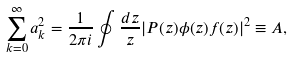Convert formula to latex. <formula><loc_0><loc_0><loc_500><loc_500>\sum _ { k = 0 } ^ { \infty } a _ { k } ^ { 2 } = \frac { 1 } { 2 \pi i } \oint \frac { d z } { z } | P ( z ) \phi ( z ) f ( z ) | ^ { 2 } \equiv A ,</formula> 